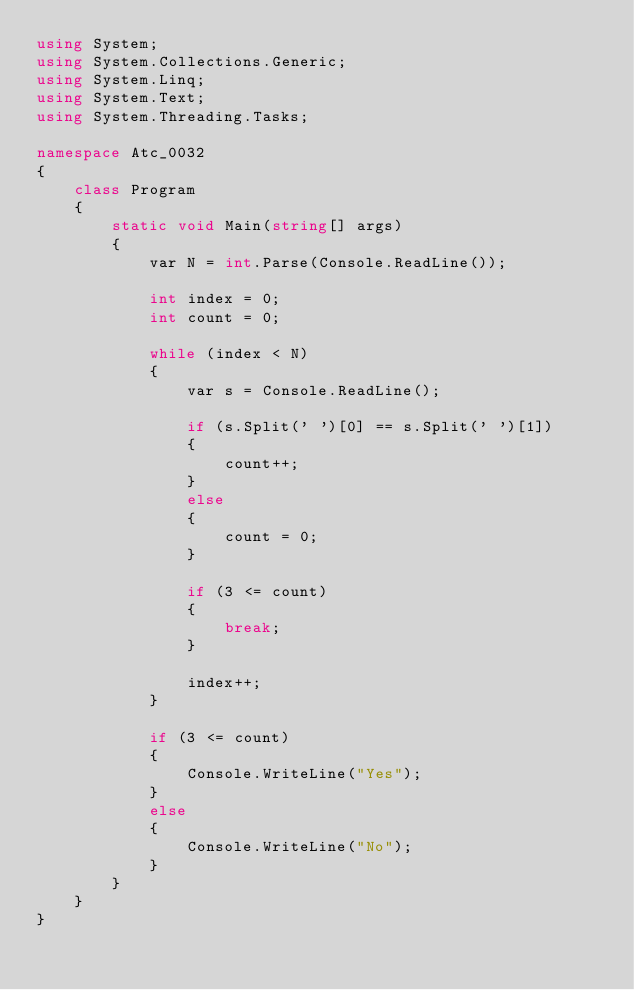Convert code to text. <code><loc_0><loc_0><loc_500><loc_500><_C#_>using System;
using System.Collections.Generic;
using System.Linq;
using System.Text;
using System.Threading.Tasks;

namespace Atc_0032
{
    class Program
    {
        static void Main(string[] args)
        {
            var N = int.Parse(Console.ReadLine());

            int index = 0;
            int count = 0;

            while (index < N)
            {
                var s = Console.ReadLine();

                if (s.Split(' ')[0] == s.Split(' ')[1])
                {
                    count++;
                }
                else
                {
                    count = 0;
                }

                if (3 <= count)
                {
                    break;
                }

                index++;
            }

            if (3 <= count)
            {
                Console.WriteLine("Yes");
            }
            else
            {
                Console.WriteLine("No");
            }
        }
    }
}
</code> 